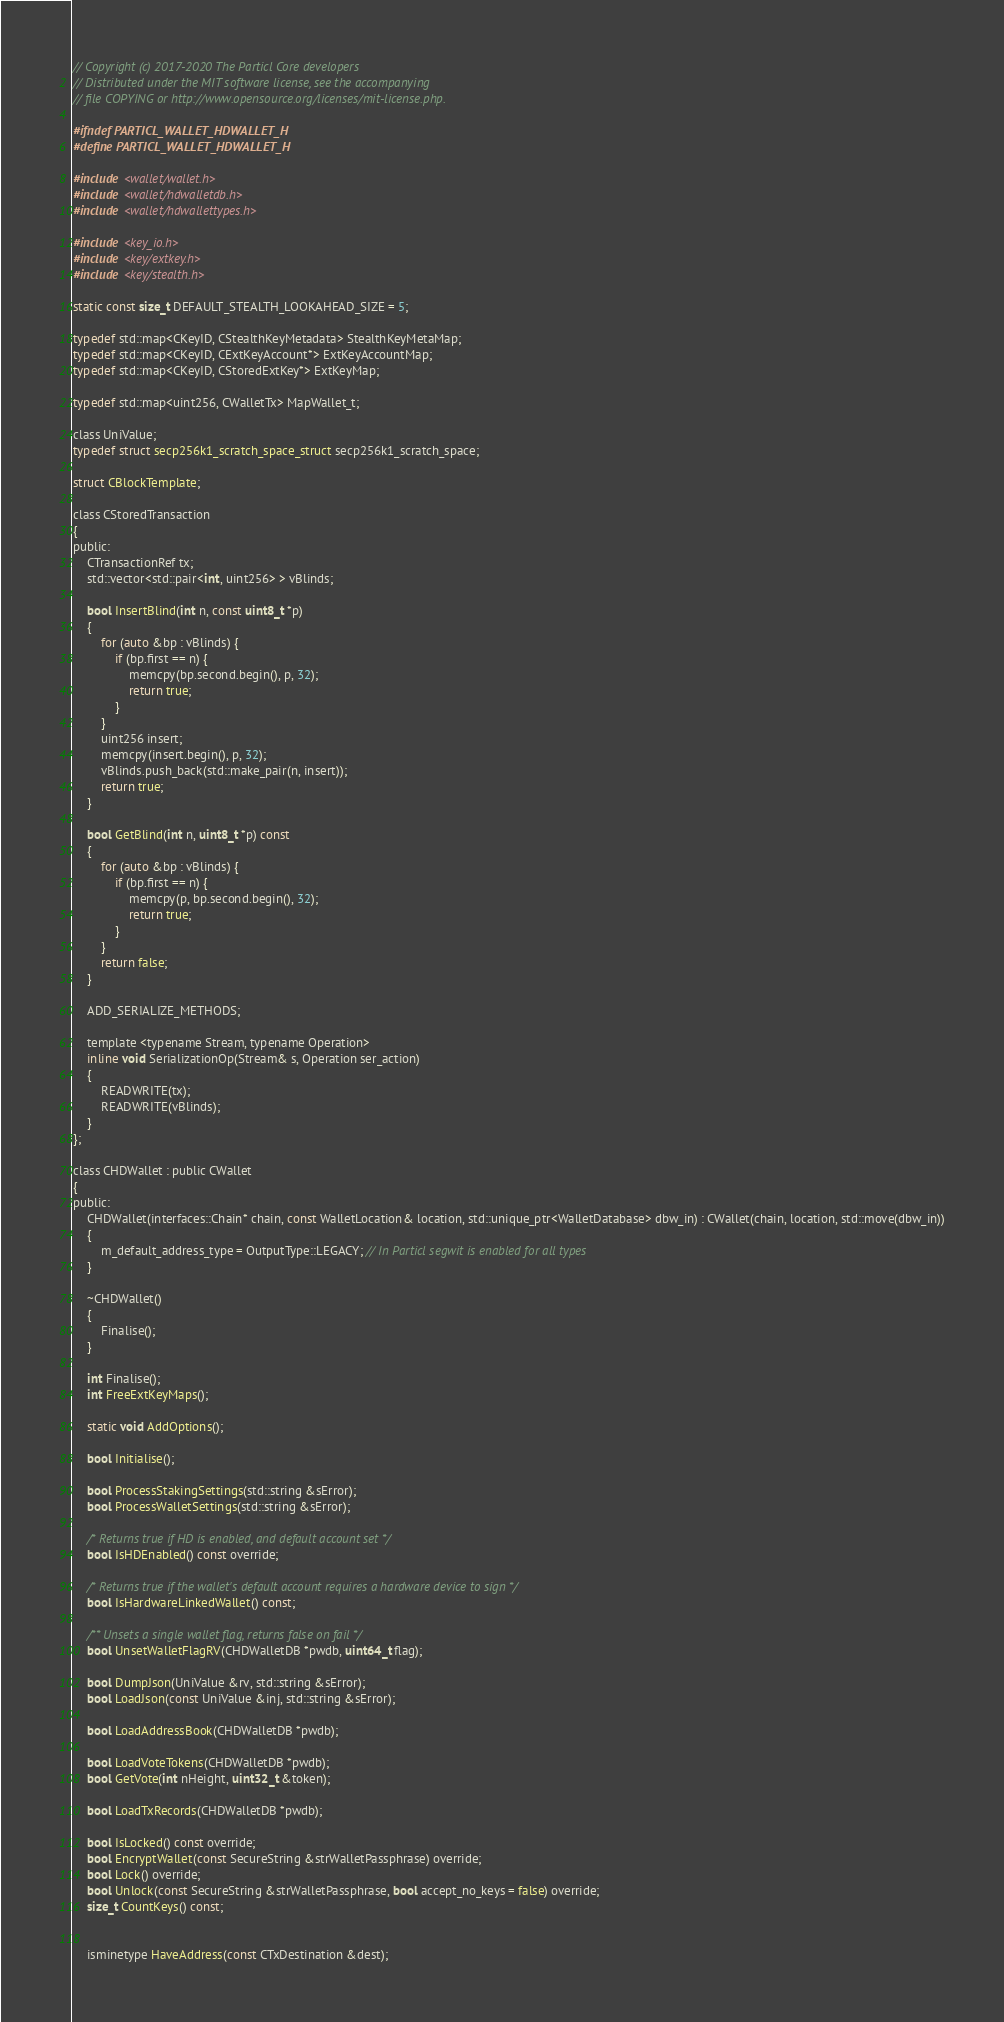<code> <loc_0><loc_0><loc_500><loc_500><_C_>// Copyright (c) 2017-2020 The Particl Core developers
// Distributed under the MIT software license, see the accompanying
// file COPYING or http://www.opensource.org/licenses/mit-license.php.

#ifndef PARTICL_WALLET_HDWALLET_H
#define PARTICL_WALLET_HDWALLET_H

#include <wallet/wallet.h>
#include <wallet/hdwalletdb.h>
#include <wallet/hdwallettypes.h>

#include <key_io.h>
#include <key/extkey.h>
#include <key/stealth.h>

static const size_t DEFAULT_STEALTH_LOOKAHEAD_SIZE = 5;

typedef std::map<CKeyID, CStealthKeyMetadata> StealthKeyMetaMap;
typedef std::map<CKeyID, CExtKeyAccount*> ExtKeyAccountMap;
typedef std::map<CKeyID, CStoredExtKey*> ExtKeyMap;

typedef std::map<uint256, CWalletTx> MapWallet_t;

class UniValue;
typedef struct secp256k1_scratch_space_struct secp256k1_scratch_space;

struct CBlockTemplate;

class CStoredTransaction
{
public:
    CTransactionRef tx;
    std::vector<std::pair<int, uint256> > vBlinds;

    bool InsertBlind(int n, const uint8_t *p)
    {
        for (auto &bp : vBlinds) {
            if (bp.first == n) {
                memcpy(bp.second.begin(), p, 32);
                return true;
            }
        }
        uint256 insert;
        memcpy(insert.begin(), p, 32);
        vBlinds.push_back(std::make_pair(n, insert));
        return true;
    }

    bool GetBlind(int n, uint8_t *p) const
    {
        for (auto &bp : vBlinds) {
            if (bp.first == n) {
                memcpy(p, bp.second.begin(), 32);
                return true;
            }
        }
        return false;
    }

    ADD_SERIALIZE_METHODS;

    template <typename Stream, typename Operation>
    inline void SerializationOp(Stream& s, Operation ser_action)
    {
        READWRITE(tx);
        READWRITE(vBlinds);
    }
};

class CHDWallet : public CWallet
{
public:
    CHDWallet(interfaces::Chain* chain, const WalletLocation& location, std::unique_ptr<WalletDatabase> dbw_in) : CWallet(chain, location, std::move(dbw_in))
    {
        m_default_address_type = OutputType::LEGACY; // In Particl segwit is enabled for all types
    }

    ~CHDWallet()
    {
        Finalise();
    }

    int Finalise();
    int FreeExtKeyMaps();

    static void AddOptions();

    bool Initialise();

    bool ProcessStakingSettings(std::string &sError);
    bool ProcessWalletSettings(std::string &sError);

    /* Returns true if HD is enabled, and default account set */
    bool IsHDEnabled() const override;

    /* Returns true if the wallet's default account requires a hardware device to sign */
    bool IsHardwareLinkedWallet() const;

    /** Unsets a single wallet flag, returns false on fail */
    bool UnsetWalletFlagRV(CHDWalletDB *pwdb, uint64_t flag);

    bool DumpJson(UniValue &rv, std::string &sError);
    bool LoadJson(const UniValue &inj, std::string &sError);

    bool LoadAddressBook(CHDWalletDB *pwdb);

    bool LoadVoteTokens(CHDWalletDB *pwdb);
    bool GetVote(int nHeight, uint32_t &token);

    bool LoadTxRecords(CHDWalletDB *pwdb);

    bool IsLocked() const override;
    bool EncryptWallet(const SecureString &strWalletPassphrase) override;
    bool Lock() override;
    bool Unlock(const SecureString &strWalletPassphrase, bool accept_no_keys = false) override;
    size_t CountKeys() const;


    isminetype HaveAddress(const CTxDestination &dest);</code> 